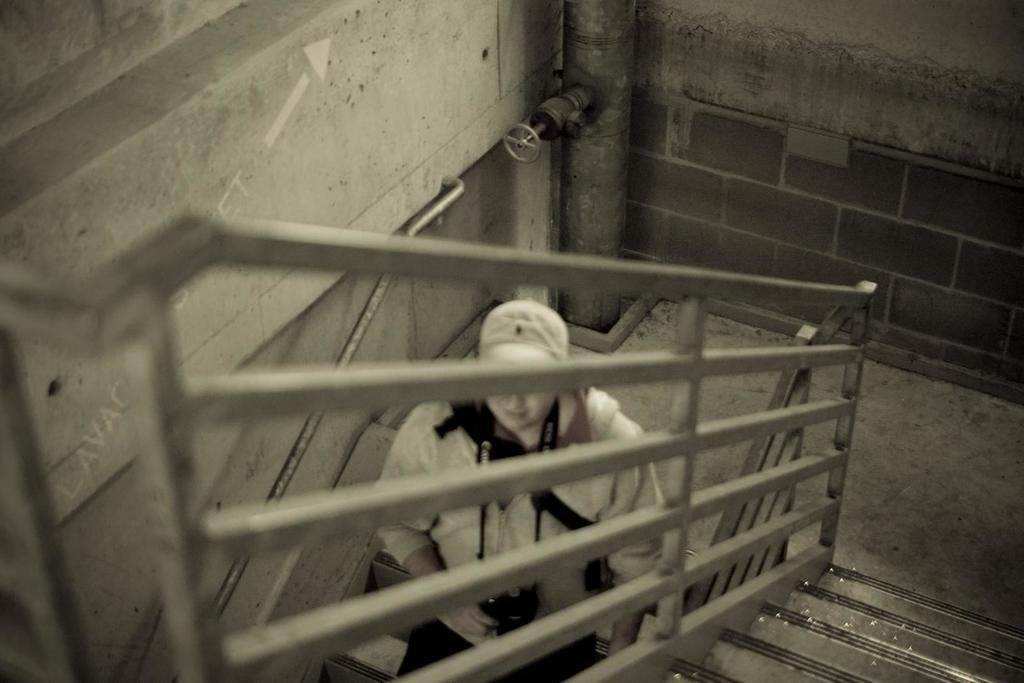What can be seen in the foreground of the image? There are stairs in the foreground of the image. What feature is present alongside the stairs? There is a railing in the image. What other architectural element is visible in the image? There is a wall in the image. What is the person in the image doing? The person is wearing a camera and walking on the stairs. What is the color scheme of the image? The image is in black and white. What type of wood is the person using to record their trip in the image? There is no wood or trip present in the image; it features a person wearing a camera and walking on stairs in a black and white setting. 